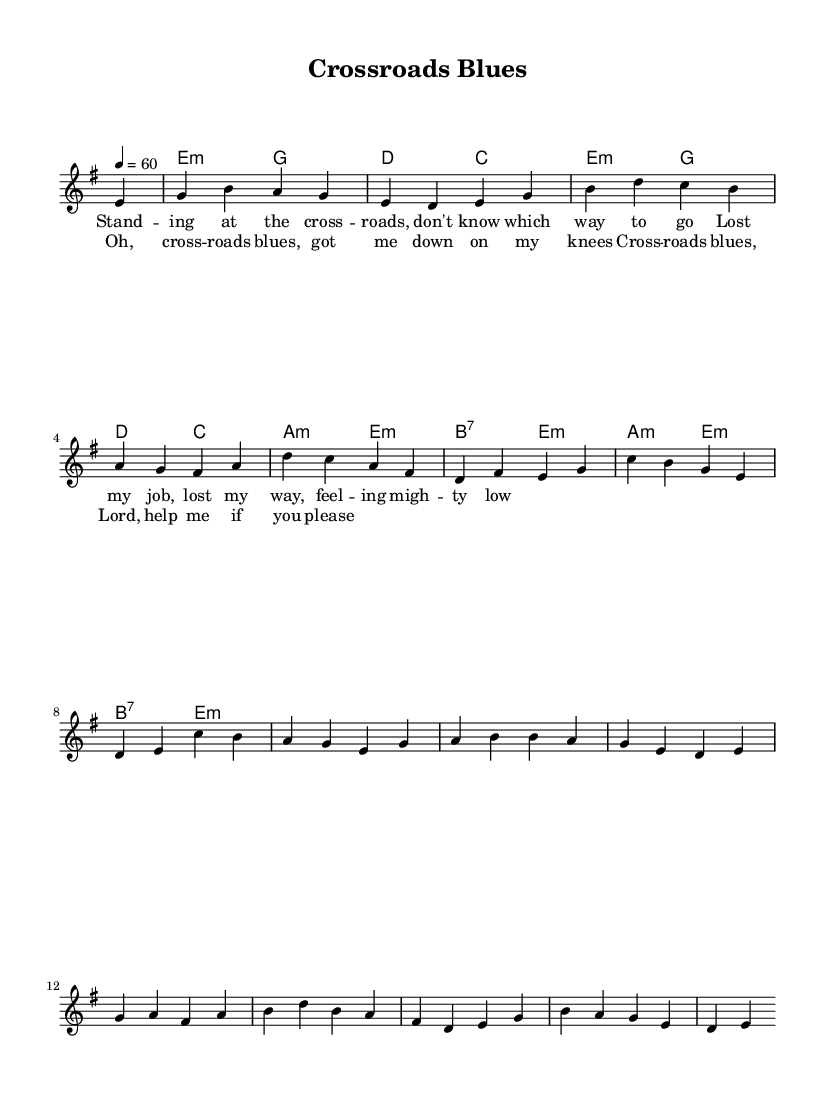What is the key signature of this music? The key signature is indicated at the beginning of the score, showing E minor with one sharp (F#).
Answer: E minor What is the time signature of this piece? The time signature appears at the start of the music and is written as 4/4, which means there are four beats in a measure.
Answer: 4/4 What is the tempo marking for this piece? The tempo marking can be found at the beginning, indicating that the piece should be played at a speed of 60 beats per minute.
Answer: 60 How many measures are in the verse? By counting the individual bars in the verse section (which is noted in the lyric lines), we find that there are 4 measures in total.
Answer: 4 What type of chord is used on the second measure? The second measure contains a G major chord, which can be identified by its notes G, B, and D in the harmonies section.
Answer: G major What is a lyrical theme present in the chorus? The chorus speaks about a plea for help, as indicated by the lyrics "Lord, help me if you please," reflecting emotional struggle common in blues.
Answer: Plea for help What is a unique characteristic of blues music as seen in this score? The presence of specific chord progressions, such as the use of minor chords and seventh chords, is a hallmark of the blues style, which creates a distinct sound.
Answer: Minor and seventh chords 